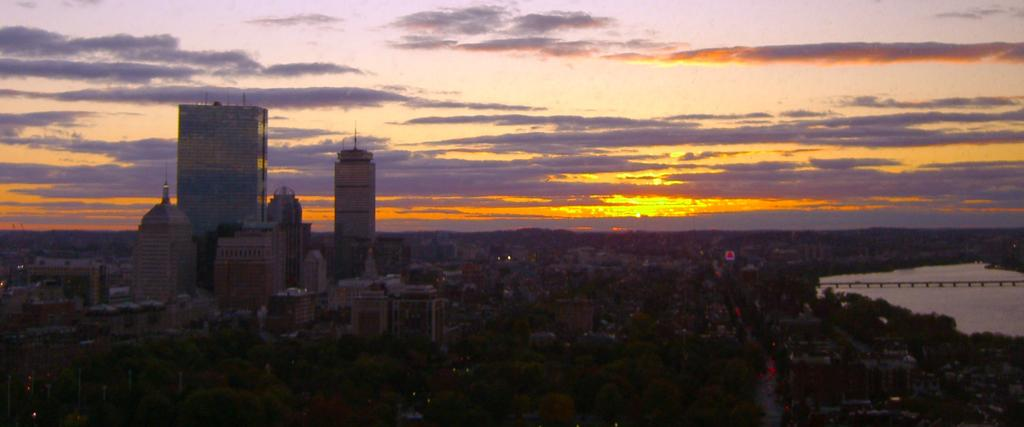What type of natural elements can be seen in the image? There are trees in the image. What type of man-made structures are present in the image? There are buildings in the image. What can be seen on the right side of the image? There is water on the right side of the image. How is the water crossed in the image? There is a bridge across the water. What is visible in the background of the image? The sky is visible in the background of the image. What can be observed in the sky? There are clouds in the sky. How many circles can be seen in the image? There are no circles present in the image. What type of bird is sitting on the hen in the image? There is no hen or bird present in the image. 